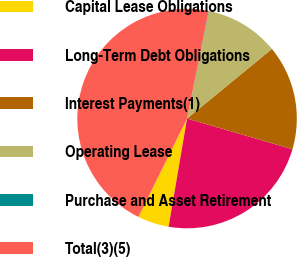Convert chart to OTSL. <chart><loc_0><loc_0><loc_500><loc_500><pie_chart><fcel>Capital Lease Obligations<fcel>Long-Term Debt Obligations<fcel>Interest Payments(1)<fcel>Operating Lease<fcel>Purchase and Asset Retirement<fcel>Total(3)(5)<nl><fcel>4.62%<fcel>23.18%<fcel>15.45%<fcel>10.86%<fcel>0.04%<fcel>45.85%<nl></chart> 